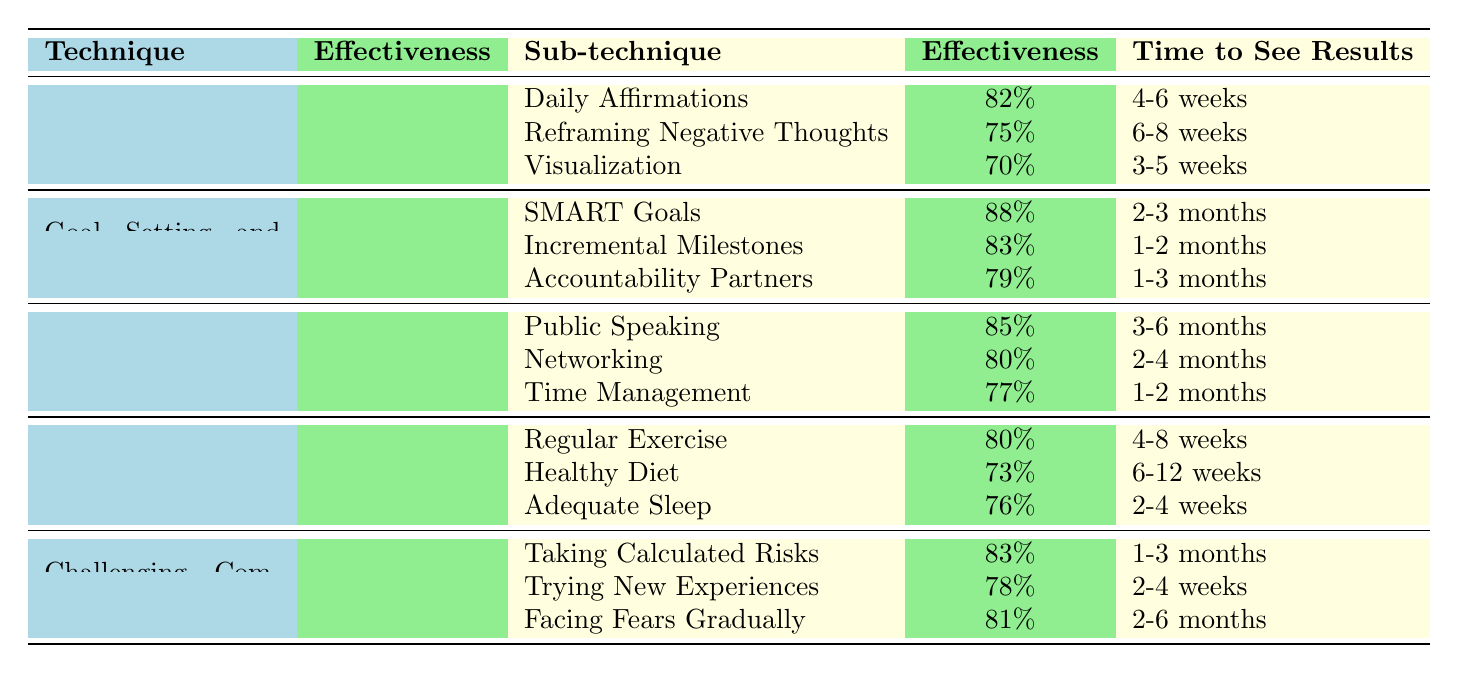What is the effectiveness rate of the "Goal Setting and Achievement" technique? The table lists "Goal Setting and Achievement" with an effectiveness rate of 85%.
Answer: 85% Which sub-technique under "Physical Self-Care" has the highest effectiveness? Among the sub-techniques listed under "Physical Self-Care," Regular Exercise has the highest effectiveness at 80%.
Answer: Regular Exercise How long does it typically take to see results from "Incremental Milestones"? The table indicates that it takes 1-2 months to see results from "Incremental Milestones."
Answer: 1-2 months What is the effectiveness difference between "Daily Affirmations" and "Visualization"? The effectiveness of "Daily Affirmations" is 82%, while "Visualization" has an effectiveness of 70%. The difference is 82% - 70% = 12%.
Answer: 12% Is the effectiveness rate of "Skill Development" higher or lower than that of "Challenging Comfort Zones"? "Skill Development" has an effectiveness rate of 82%, while "Challenging Comfort Zones" has 80%. Therefore, it is higher.
Answer: Higher If we average the effectiveness rates of all techniques, what would be the result? The effectiveness rates are 78%, 85%, 82%, 75%, and 80%. Summing these gives 400% over 5 techniques, resulting in an average of 400/5 = 80%.
Answer: 80% Which technique has the lowest effectiveness rate, and what is it? Looking at the table, "Physical Self-Care" has the lowest effectiveness rate at 75%.
Answer: Physical Self-Care at 75% How many sub-techniques have an effectiveness rate above 80%? The sub-techniques with effectiveness above 80% are Daily Affirmations (82%), SMART Goals (88%), Public Speaking (85%), and Taking Calculated Risks (83%). This counts as 4 sub-techniques.
Answer: 4 Is "Facing Fears Gradually" more effective than "Trying New Experiences"? "Facing Fears Gradually" has an effectiveness rate of 81%, which is higher than "Trying New Experiences" at 78%.
Answer: Yes What is the time to see results for the sub-technique with the lowest effectiveness under "Self-Care"? Under "Physical Self-Care," the sub-technique "Healthy Diet" has the lowest effectiveness at 73% with a time to see results of 6-12 weeks.
Answer: 6-12 weeks 